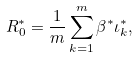<formula> <loc_0><loc_0><loc_500><loc_500>R ^ { * } _ { 0 } = \frac { 1 } { m } \sum _ { k = 1 } ^ { m } \beta ^ { * } \iota ^ { * } _ { k } ,</formula> 